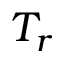Convert formula to latex. <formula><loc_0><loc_0><loc_500><loc_500>T _ { r }</formula> 